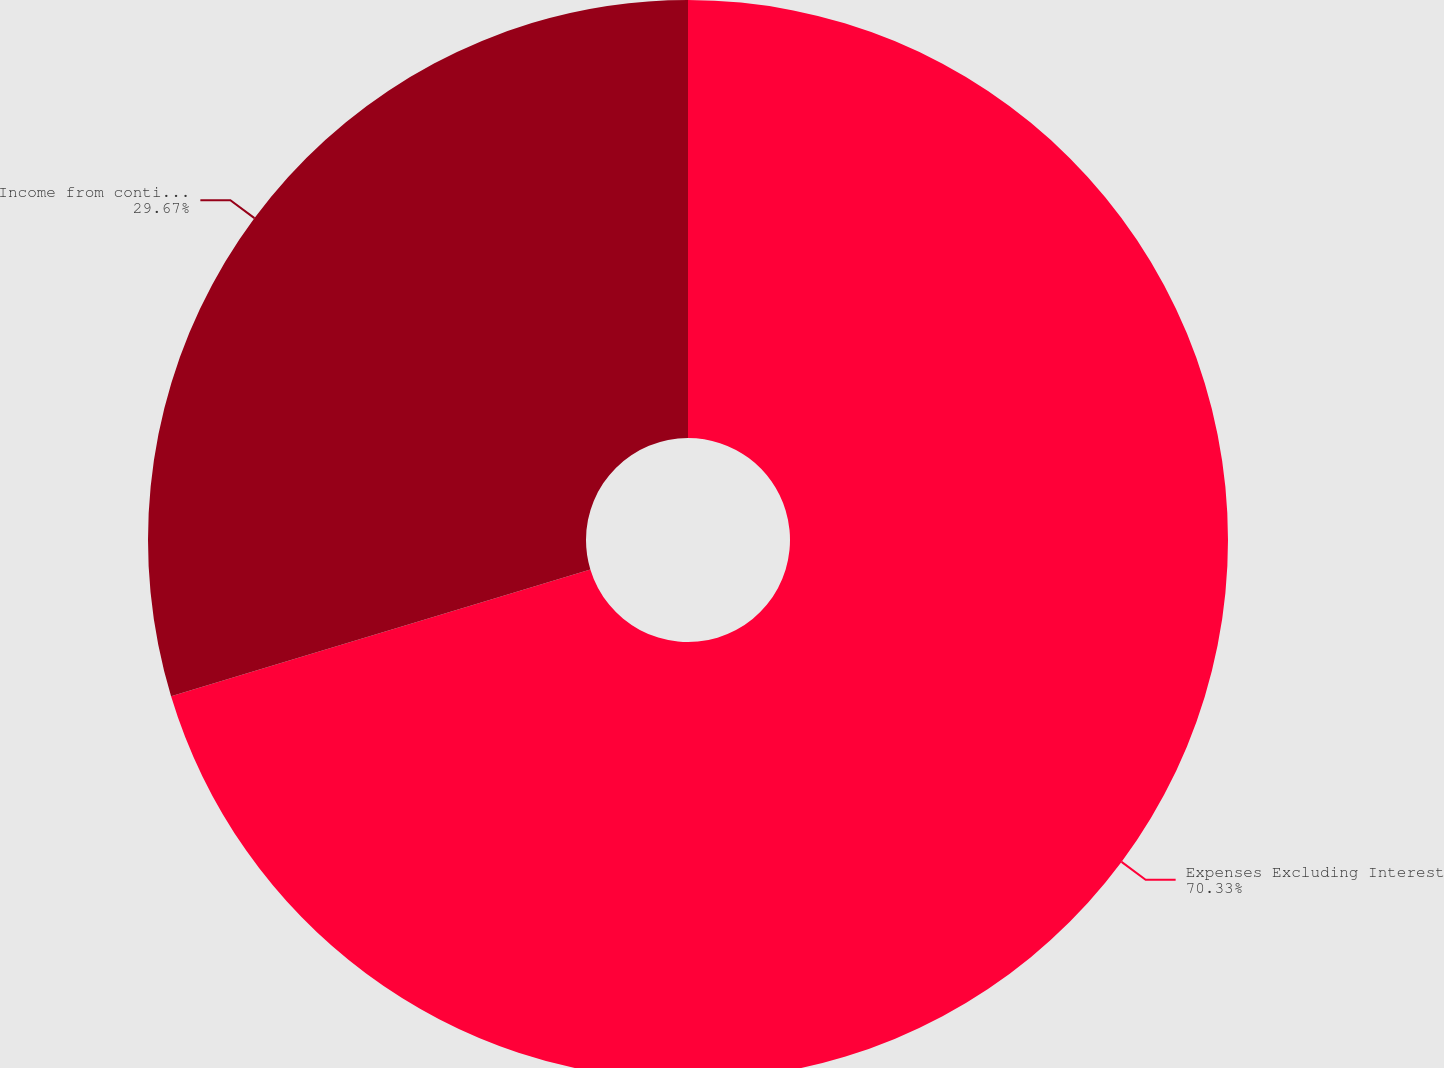Convert chart. <chart><loc_0><loc_0><loc_500><loc_500><pie_chart><fcel>Expenses Excluding Interest<fcel>Income from continuing<nl><fcel>70.33%<fcel>29.67%<nl></chart> 